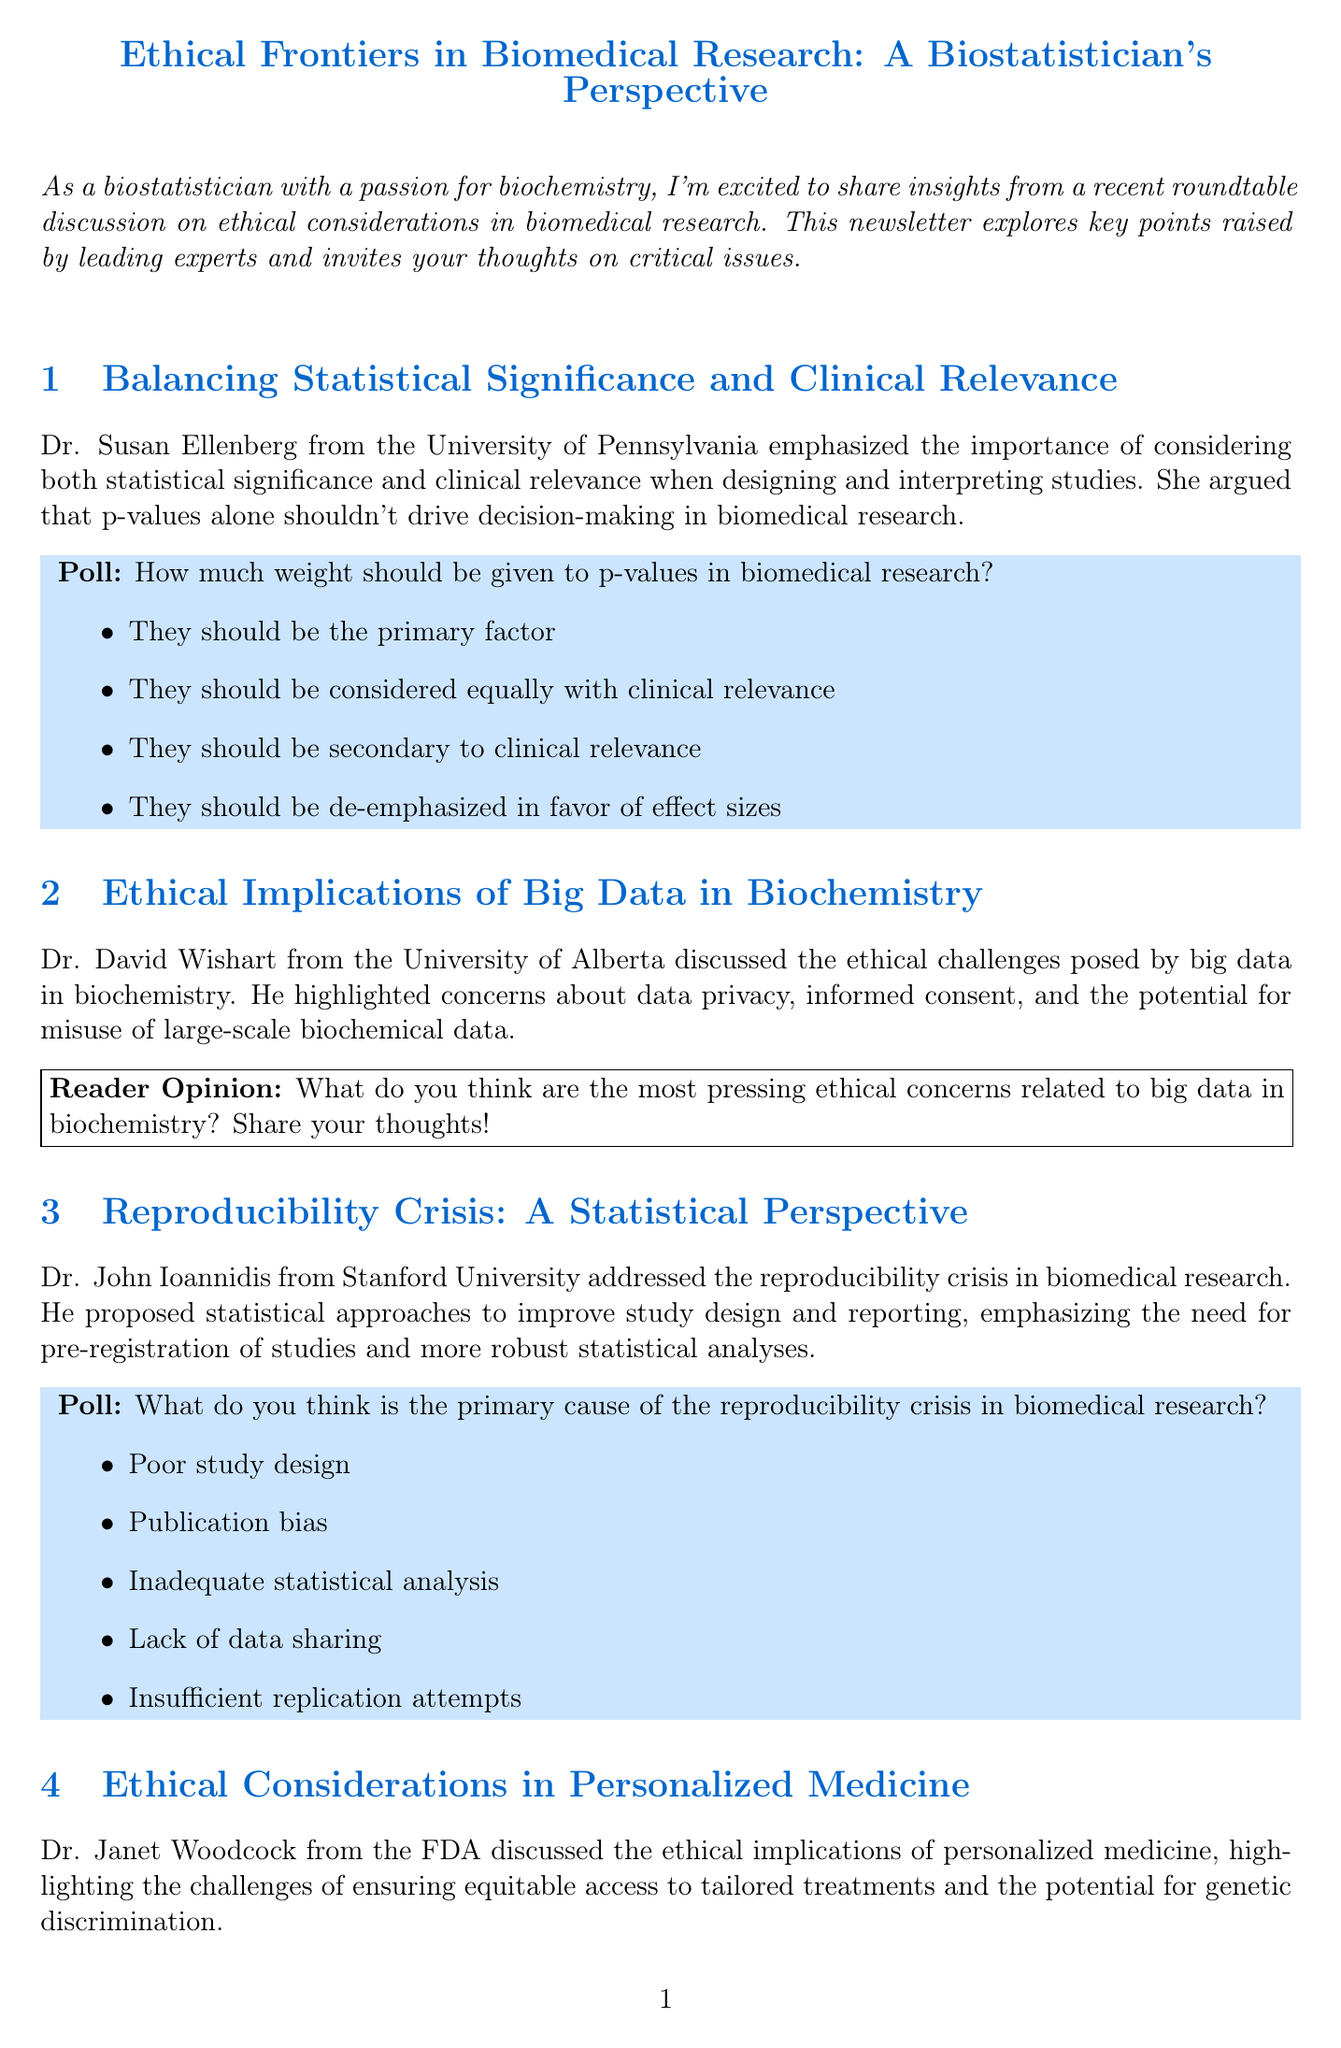What is the title of the newsletter? The title of the newsletter is provided at the beginning of the document.
Answer: Ethical Frontiers in Biomedical Research: A Biostatistician's Perspective Who emphasized the importance of statistical significance and clinical relevance? Dr. Susan Ellenberg's name is mentioned in the context of this topic.
Answer: Dr. Susan Ellenberg What ethical challenges are associated with big data in biochemistry? The document lists specific concerns from Dr. David Wishart regarding data privacy and consent.
Answer: Data privacy, informed consent, misuse What is the date of the upcoming workshop on ethical data analysis? The specific date for the workshop is mentioned in the upcoming events section.
Answer: October 5, 2023 Which university does Dr. John Ioannidis represent? The document states that Dr. Ioannidis is from Stanford University.
Answer: Stanford University What is the main focus of the recommended reading list? The titles mentioned are about ethical considerations and statistical approaches in biostatistics and biochemistry.
Answer: Ethics and statistics in biomedicine What was Dr. Marie-Pierre Dubé's quote about the role of biostatisticians? The quote highlights the responsibilities of biostatisticians regarding ethical implications.
Answer: Responsibility to ensure scientific rigor and ethical implications How many poll questions are included in the document? The document contains two poll questions related to different ethical topics in biomedical research.
Answer: Two 